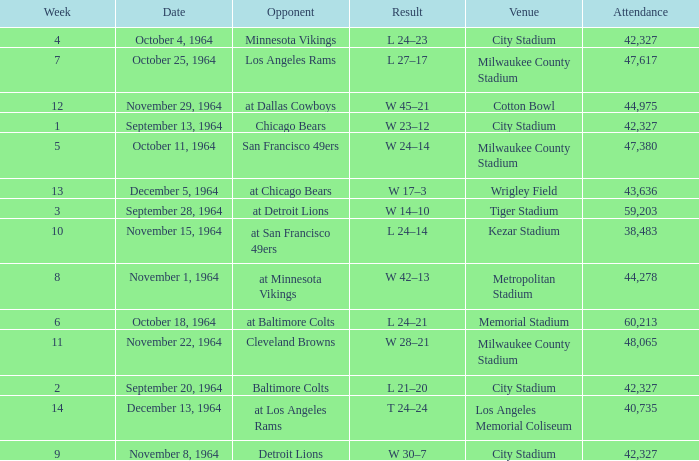What venue held that game with a result of l 24–14? Kezar Stadium. 